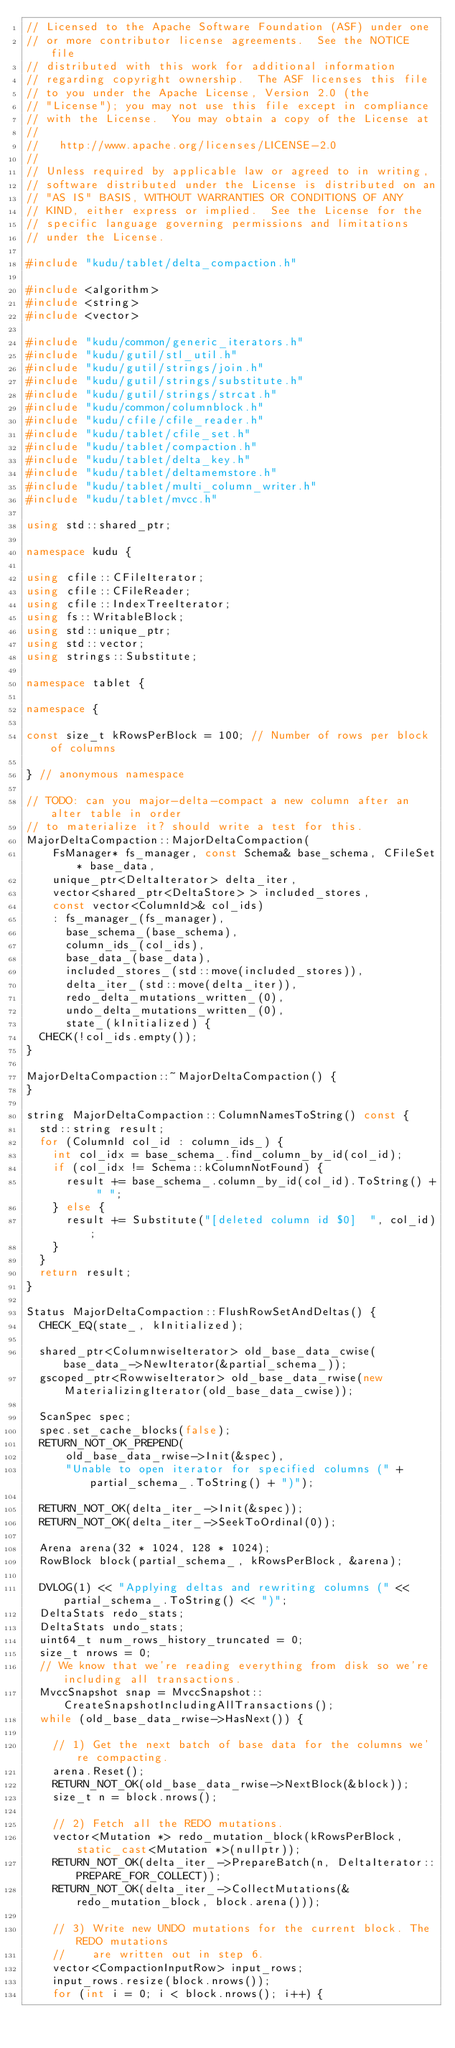Convert code to text. <code><loc_0><loc_0><loc_500><loc_500><_C++_>// Licensed to the Apache Software Foundation (ASF) under one
// or more contributor license agreements.  See the NOTICE file
// distributed with this work for additional information
// regarding copyright ownership.  The ASF licenses this file
// to you under the Apache License, Version 2.0 (the
// "License"); you may not use this file except in compliance
// with the License.  You may obtain a copy of the License at
//
//   http://www.apache.org/licenses/LICENSE-2.0
//
// Unless required by applicable law or agreed to in writing,
// software distributed under the License is distributed on an
// "AS IS" BASIS, WITHOUT WARRANTIES OR CONDITIONS OF ANY
// KIND, either express or implied.  See the License for the
// specific language governing permissions and limitations
// under the License.

#include "kudu/tablet/delta_compaction.h"

#include <algorithm>
#include <string>
#include <vector>

#include "kudu/common/generic_iterators.h"
#include "kudu/gutil/stl_util.h"
#include "kudu/gutil/strings/join.h"
#include "kudu/gutil/strings/substitute.h"
#include "kudu/gutil/strings/strcat.h"
#include "kudu/common/columnblock.h"
#include "kudu/cfile/cfile_reader.h"
#include "kudu/tablet/cfile_set.h"
#include "kudu/tablet/compaction.h"
#include "kudu/tablet/delta_key.h"
#include "kudu/tablet/deltamemstore.h"
#include "kudu/tablet/multi_column_writer.h"
#include "kudu/tablet/mvcc.h"

using std::shared_ptr;

namespace kudu {

using cfile::CFileIterator;
using cfile::CFileReader;
using cfile::IndexTreeIterator;
using fs::WritableBlock;
using std::unique_ptr;
using std::vector;
using strings::Substitute;

namespace tablet {

namespace {

const size_t kRowsPerBlock = 100; // Number of rows per block of columns

} // anonymous namespace

// TODO: can you major-delta-compact a new column after an alter table in order
// to materialize it? should write a test for this.
MajorDeltaCompaction::MajorDeltaCompaction(
    FsManager* fs_manager, const Schema& base_schema, CFileSet* base_data,
    unique_ptr<DeltaIterator> delta_iter,
    vector<shared_ptr<DeltaStore> > included_stores,
    const vector<ColumnId>& col_ids)
    : fs_manager_(fs_manager),
      base_schema_(base_schema),
      column_ids_(col_ids),
      base_data_(base_data),
      included_stores_(std::move(included_stores)),
      delta_iter_(std::move(delta_iter)),
      redo_delta_mutations_written_(0),
      undo_delta_mutations_written_(0),
      state_(kInitialized) {
  CHECK(!col_ids.empty());
}

MajorDeltaCompaction::~MajorDeltaCompaction() {
}

string MajorDeltaCompaction::ColumnNamesToString() const {
  std::string result;
  for (ColumnId col_id : column_ids_) {
    int col_idx = base_schema_.find_column_by_id(col_id);
    if (col_idx != Schema::kColumnNotFound) {
      result += base_schema_.column_by_id(col_id).ToString() + " ";
    } else {
      result += Substitute("[deleted column id $0]  ", col_id);
    }
  }
  return result;
}

Status MajorDeltaCompaction::FlushRowSetAndDeltas() {
  CHECK_EQ(state_, kInitialized);

  shared_ptr<ColumnwiseIterator> old_base_data_cwise(base_data_->NewIterator(&partial_schema_));
  gscoped_ptr<RowwiseIterator> old_base_data_rwise(new MaterializingIterator(old_base_data_cwise));

  ScanSpec spec;
  spec.set_cache_blocks(false);
  RETURN_NOT_OK_PREPEND(
      old_base_data_rwise->Init(&spec),
      "Unable to open iterator for specified columns (" + partial_schema_.ToString() + ")");

  RETURN_NOT_OK(delta_iter_->Init(&spec));
  RETURN_NOT_OK(delta_iter_->SeekToOrdinal(0));

  Arena arena(32 * 1024, 128 * 1024);
  RowBlock block(partial_schema_, kRowsPerBlock, &arena);

  DVLOG(1) << "Applying deltas and rewriting columns (" << partial_schema_.ToString() << ")";
  DeltaStats redo_stats;
  DeltaStats undo_stats;
  uint64_t num_rows_history_truncated = 0;
  size_t nrows = 0;
  // We know that we're reading everything from disk so we're including all transactions.
  MvccSnapshot snap = MvccSnapshot::CreateSnapshotIncludingAllTransactions();
  while (old_base_data_rwise->HasNext()) {

    // 1) Get the next batch of base data for the columns we're compacting.
    arena.Reset();
    RETURN_NOT_OK(old_base_data_rwise->NextBlock(&block));
    size_t n = block.nrows();

    // 2) Fetch all the REDO mutations.
    vector<Mutation *> redo_mutation_block(kRowsPerBlock, static_cast<Mutation *>(nullptr));
    RETURN_NOT_OK(delta_iter_->PrepareBatch(n, DeltaIterator::PREPARE_FOR_COLLECT));
    RETURN_NOT_OK(delta_iter_->CollectMutations(&redo_mutation_block, block.arena()));

    // 3) Write new UNDO mutations for the current block. The REDO mutations
    //    are written out in step 6.
    vector<CompactionInputRow> input_rows;
    input_rows.resize(block.nrows());
    for (int i = 0; i < block.nrows(); i++) {</code> 